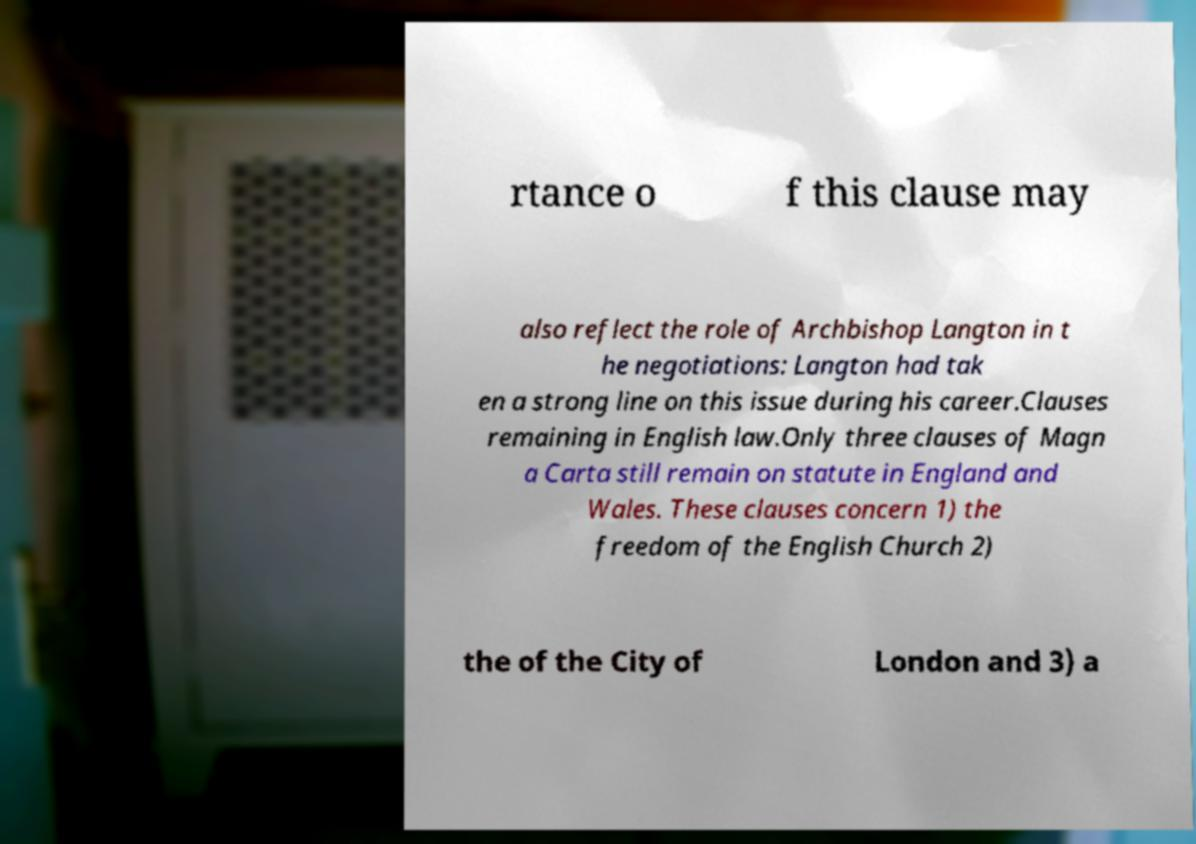Could you assist in decoding the text presented in this image and type it out clearly? rtance o f this clause may also reflect the role of Archbishop Langton in t he negotiations: Langton had tak en a strong line on this issue during his career.Clauses remaining in English law.Only three clauses of Magn a Carta still remain on statute in England and Wales. These clauses concern 1) the freedom of the English Church 2) the of the City of London and 3) a 